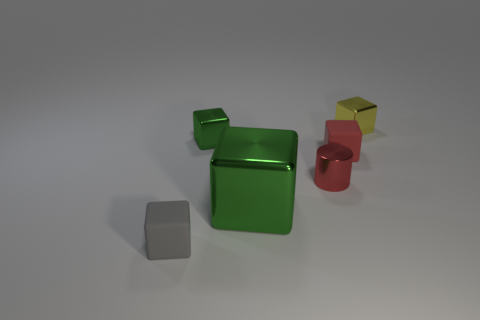How does the lighting affect the perception of the objects? The lighting in the image creates soft shadows that give the objects a three-dimensional appearance and enhance the perception of their shapes. It also highlights the reflective qualities of the materials, providing clues about their textures. 